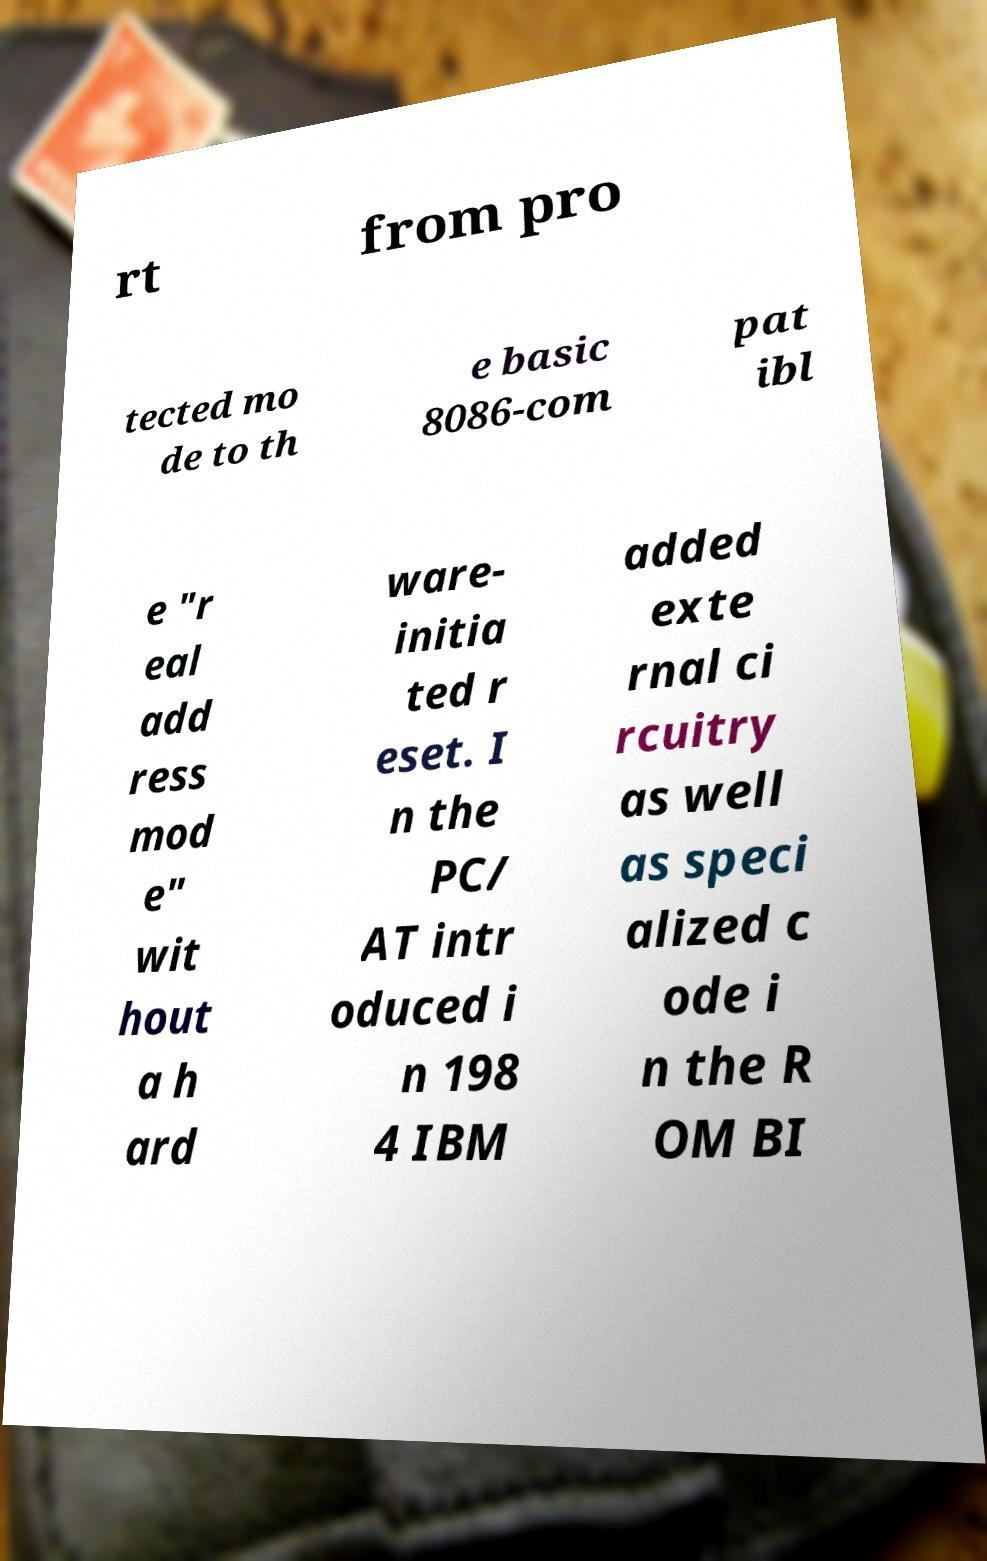Can you read and provide the text displayed in the image?This photo seems to have some interesting text. Can you extract and type it out for me? rt from pro tected mo de to th e basic 8086-com pat ibl e "r eal add ress mod e" wit hout a h ard ware- initia ted r eset. I n the PC/ AT intr oduced i n 198 4 IBM added exte rnal ci rcuitry as well as speci alized c ode i n the R OM BI 